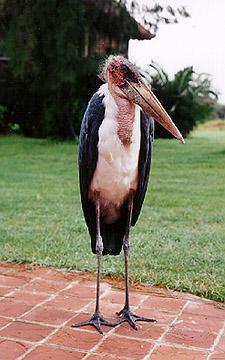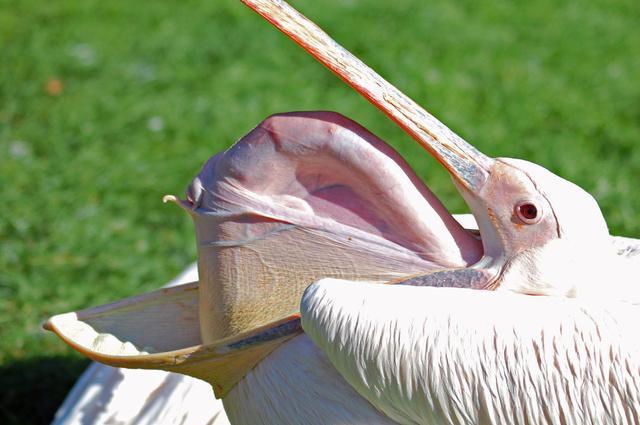The first image is the image on the left, the second image is the image on the right. For the images displayed, is the sentence "One image shows a pelican with its bill closing around the head of an animal that is not a fish, and the other image shows a forward facing open-mouthed pelican." factually correct? Answer yes or no. No. The first image is the image on the left, the second image is the image on the right. For the images shown, is this caption "In one image, a pelican's beak is open wide so the inside can be seen, while in the other image, a pelican has an animal caught in its beak." true? Answer yes or no. No. 